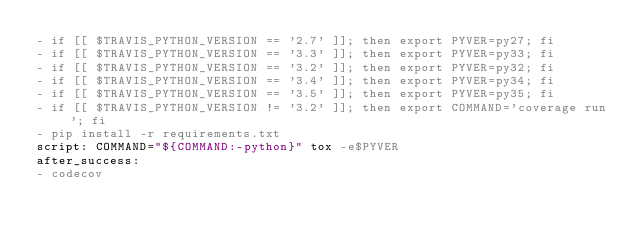<code> <loc_0><loc_0><loc_500><loc_500><_YAML_>- if [[ $TRAVIS_PYTHON_VERSION == '2.7' ]]; then export PYVER=py27; fi
- if [[ $TRAVIS_PYTHON_VERSION == '3.3' ]]; then export PYVER=py33; fi
- if [[ $TRAVIS_PYTHON_VERSION == '3.2' ]]; then export PYVER=py32; fi
- if [[ $TRAVIS_PYTHON_VERSION == '3.4' ]]; then export PYVER=py34; fi
- if [[ $TRAVIS_PYTHON_VERSION == '3.5' ]]; then export PYVER=py35; fi
- if [[ $TRAVIS_PYTHON_VERSION != '3.2' ]]; then export COMMAND='coverage run'; fi
- pip install -r requirements.txt
script: COMMAND="${COMMAND:-python}" tox -e$PYVER
after_success:
- codecov
</code> 